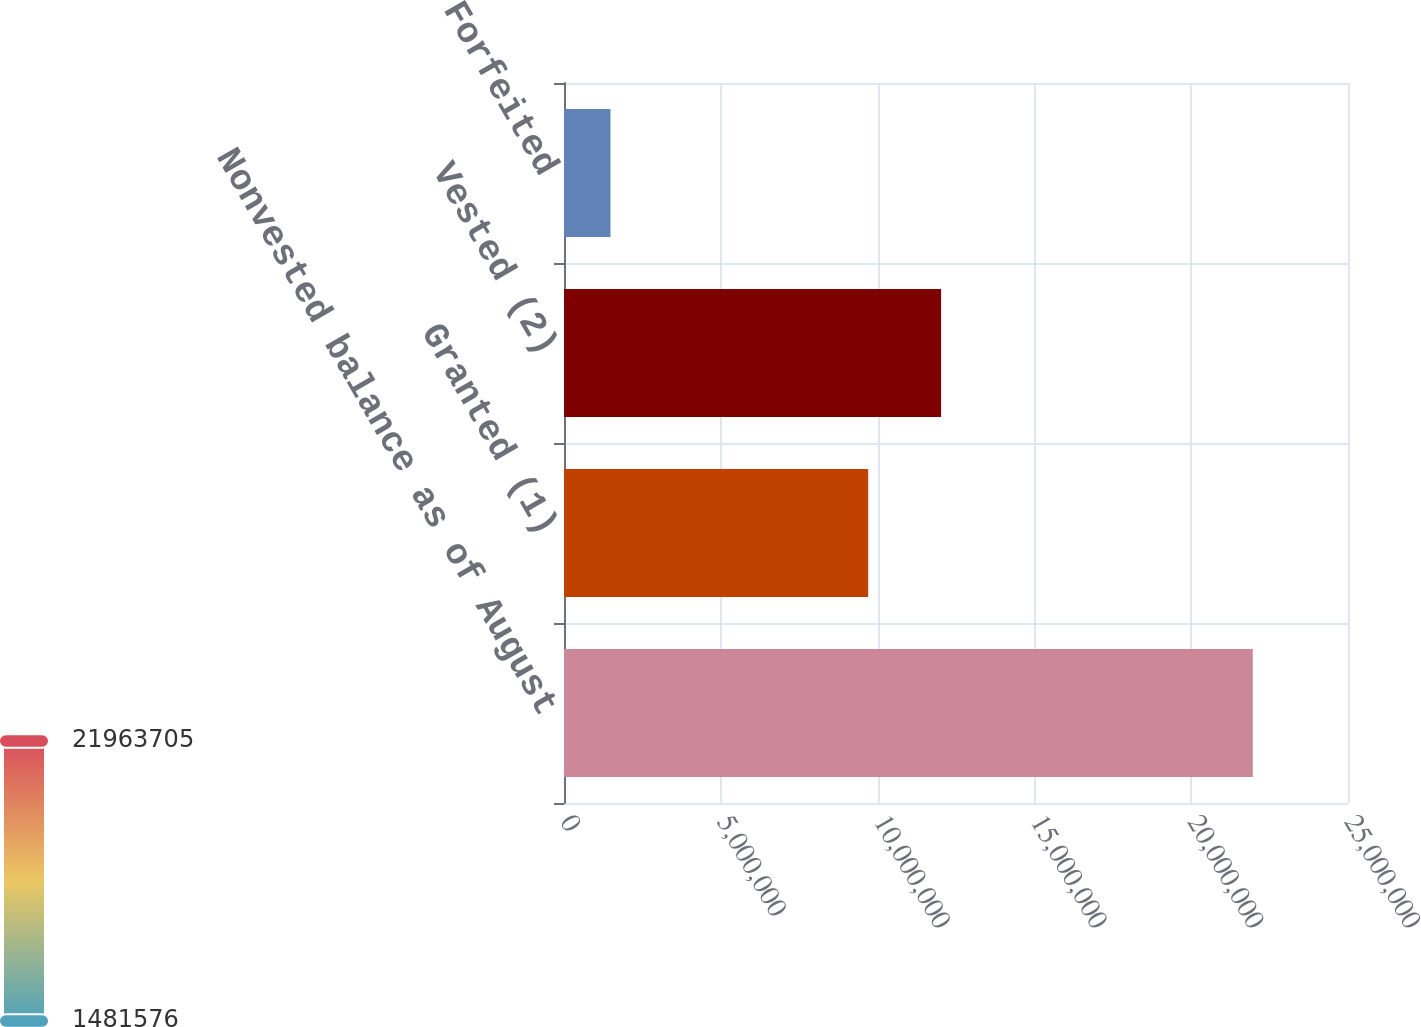<chart> <loc_0><loc_0><loc_500><loc_500><bar_chart><fcel>Nonvested balance as of August<fcel>Granted (1)<fcel>Vested (2)<fcel>Forfeited<nl><fcel>2.19637e+07<fcel>9.69969e+06<fcel>1.20249e+07<fcel>1.48158e+06<nl></chart> 